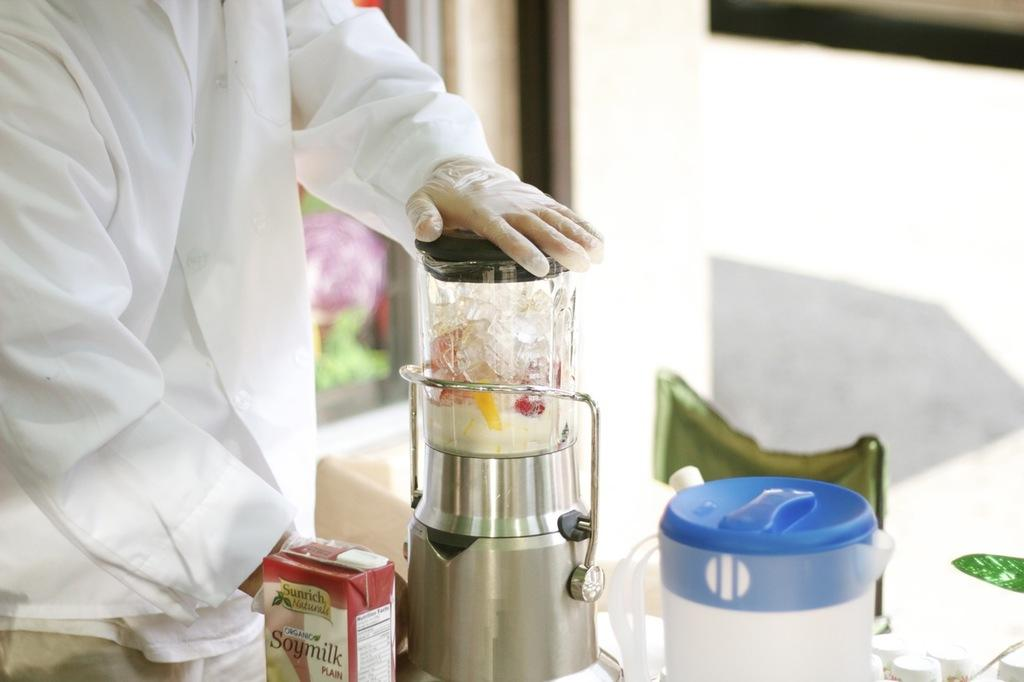<image>
Create a compact narrative representing the image presented. The blender is mixing a bunch of things including soy milk 